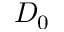<formula> <loc_0><loc_0><loc_500><loc_500>D _ { 0 }</formula> 